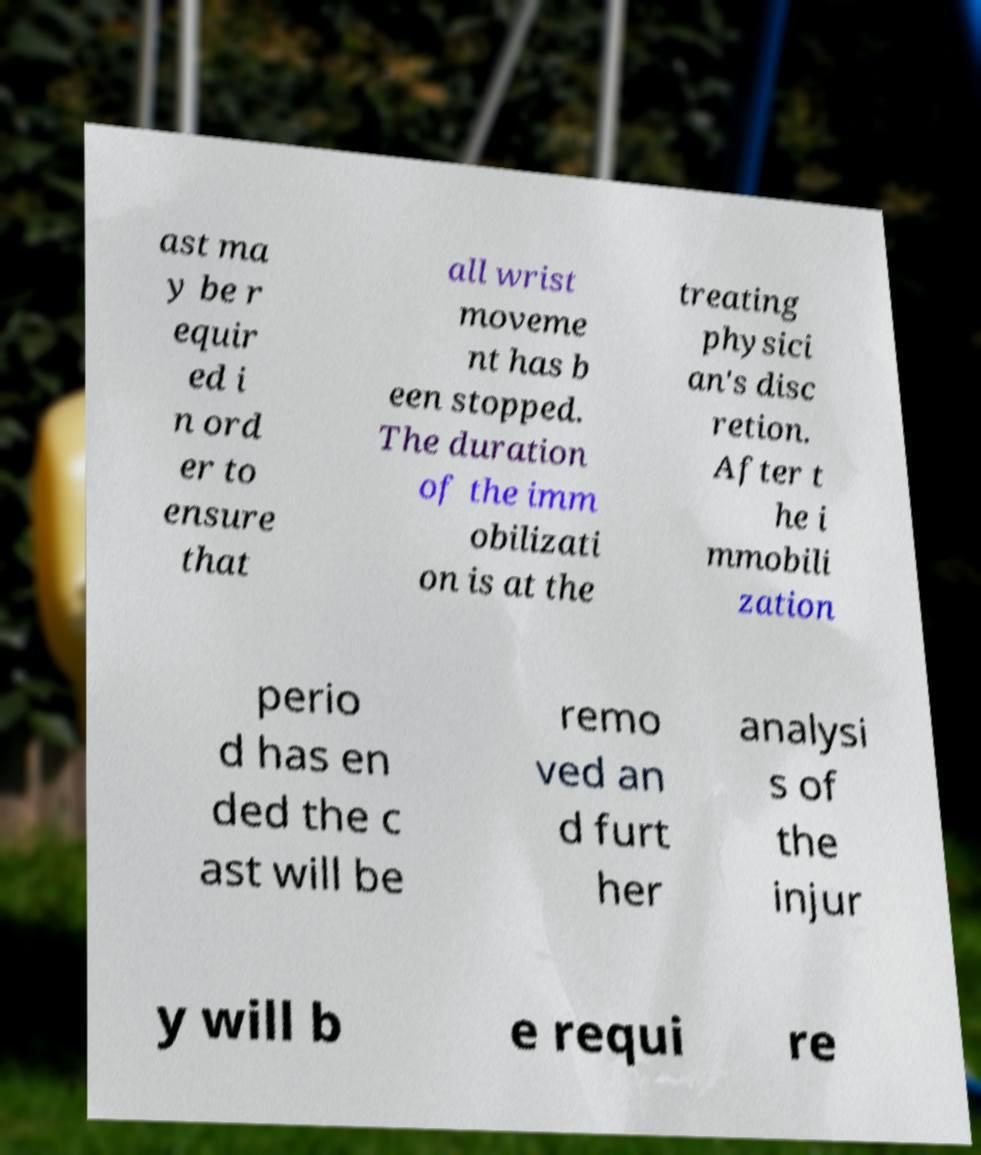I need the written content from this picture converted into text. Can you do that? ast ma y be r equir ed i n ord er to ensure that all wrist moveme nt has b een stopped. The duration of the imm obilizati on is at the treating physici an's disc retion. After t he i mmobili zation perio d has en ded the c ast will be remo ved an d furt her analysi s of the injur y will b e requi re 